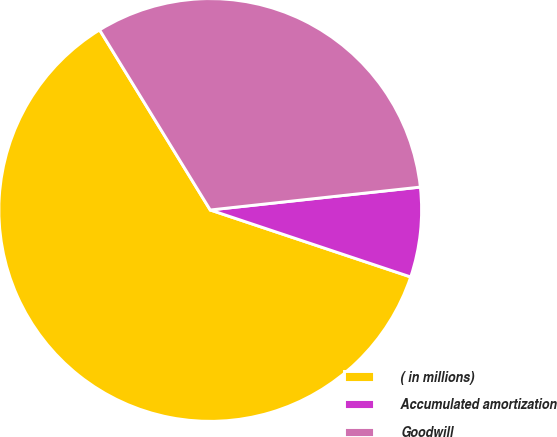Convert chart to OTSL. <chart><loc_0><loc_0><loc_500><loc_500><pie_chart><fcel>( in millions)<fcel>Accumulated amortization<fcel>Goodwill<nl><fcel>61.1%<fcel>6.86%<fcel>32.04%<nl></chart> 